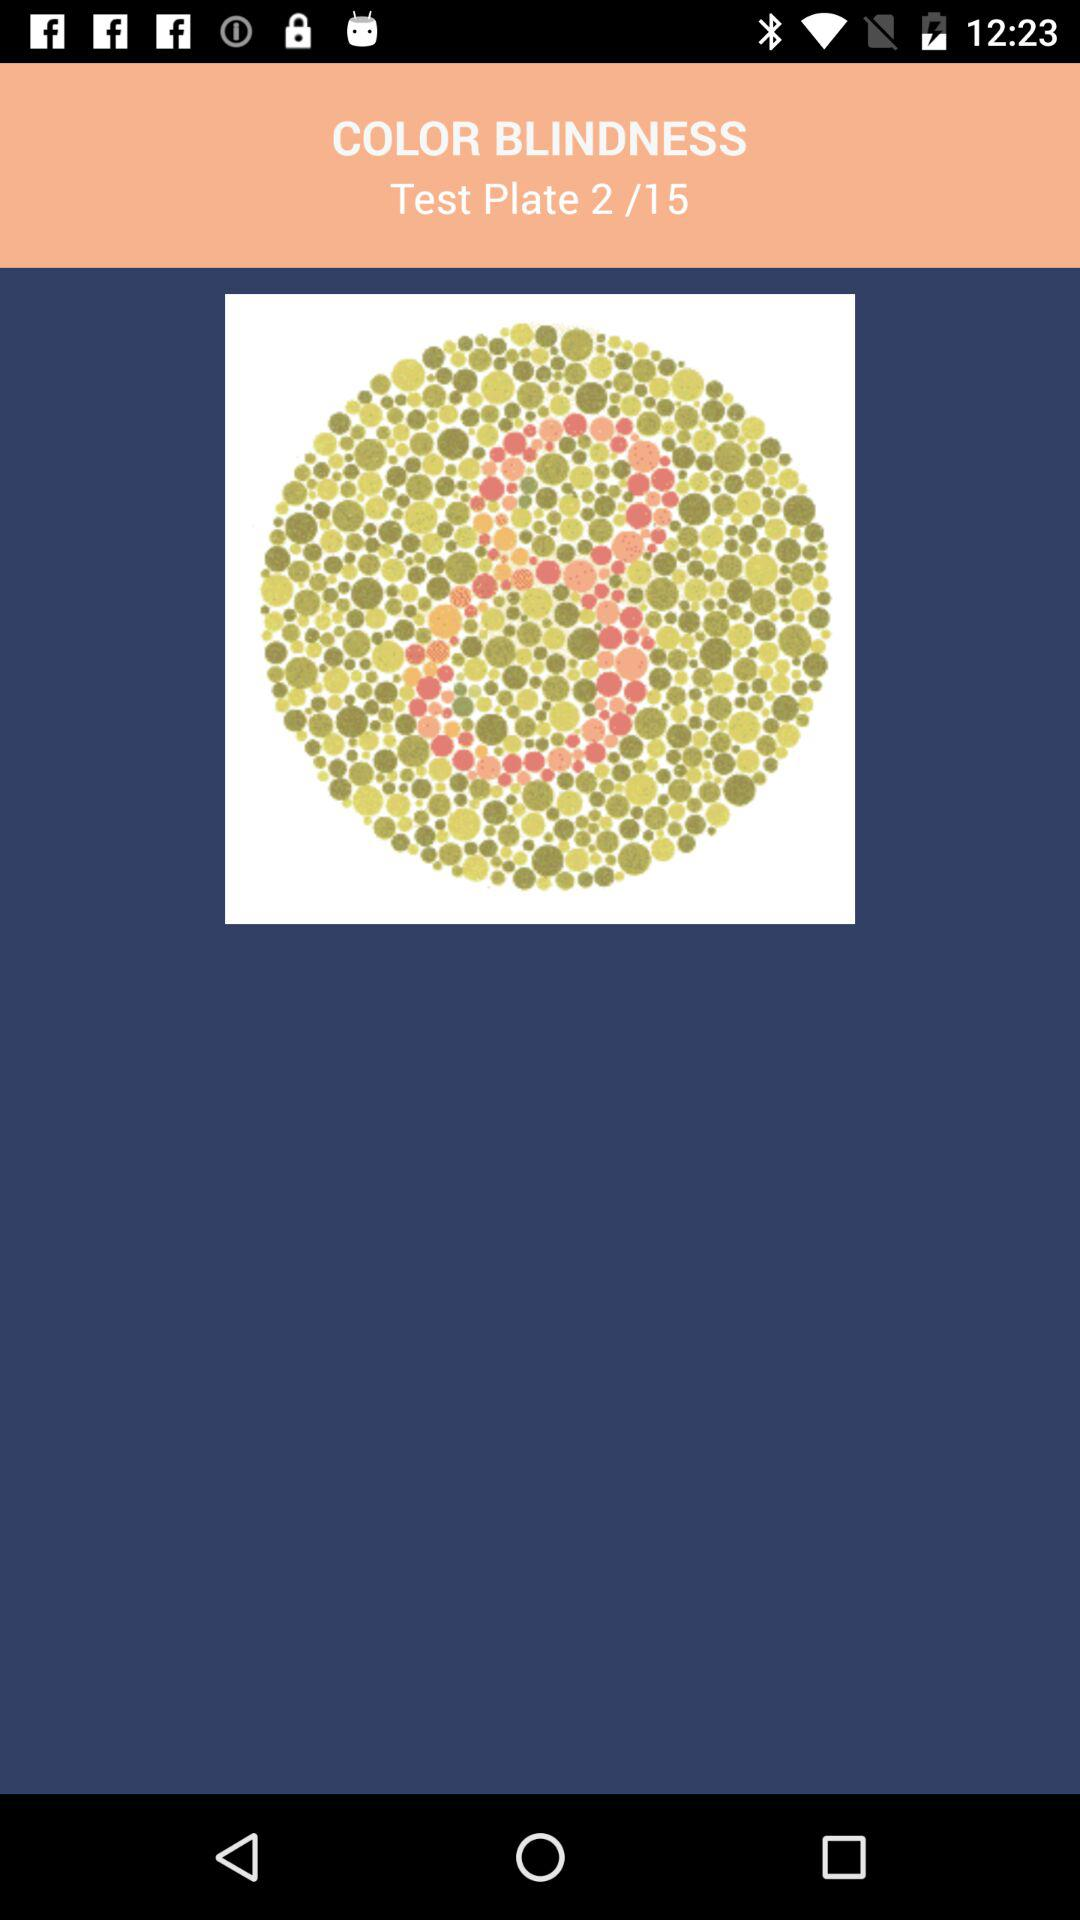How many test plates are there for color blindness? There are 15 test plates. 